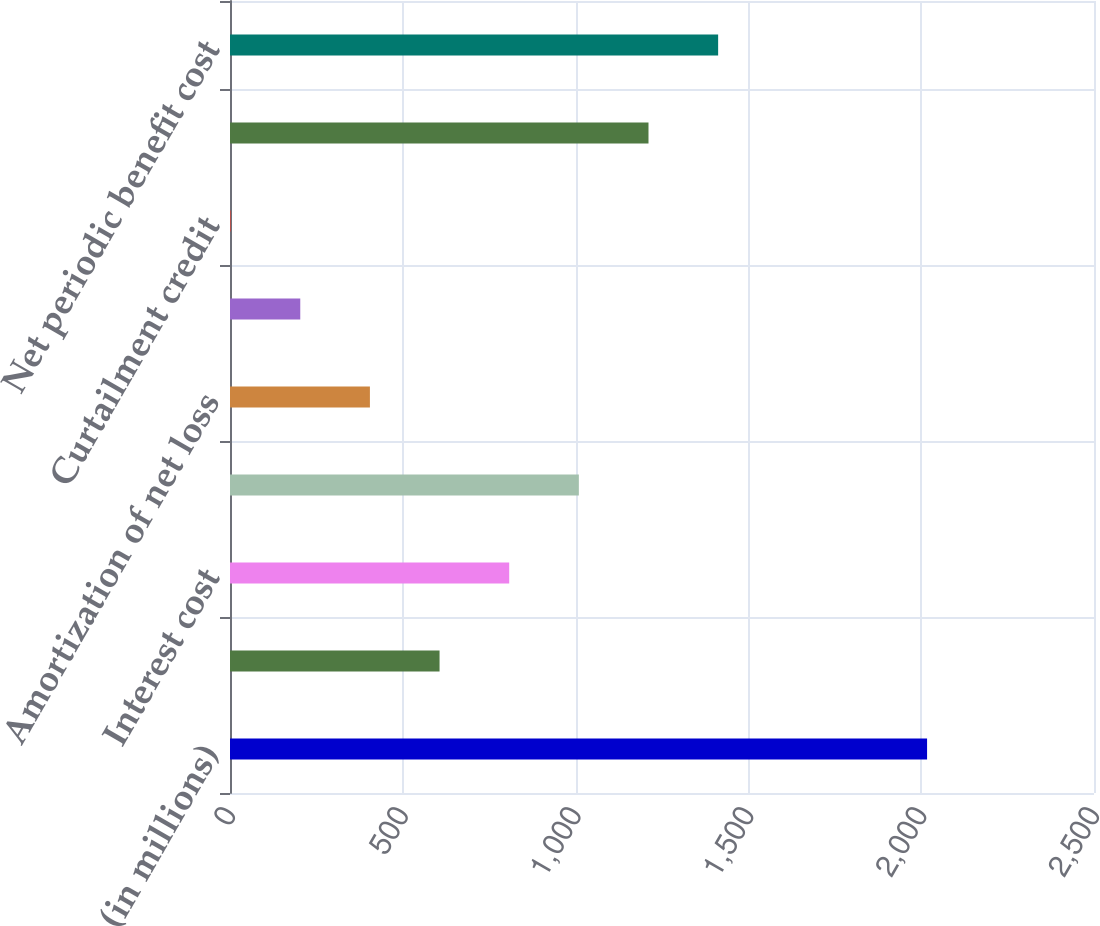<chart> <loc_0><loc_0><loc_500><loc_500><bar_chart><fcel>(in millions)<fcel>Service cost<fcel>Interest cost<fcel>Expected return on plan assets<fcel>Amortization of net loss<fcel>Amortization of prior service<fcel>Curtailment credit<fcel>Settlement costs<fcel>Net periodic benefit cost<nl><fcel>2017<fcel>606.36<fcel>807.88<fcel>1009.4<fcel>404.84<fcel>203.32<fcel>1.8<fcel>1210.92<fcel>1412.44<nl></chart> 